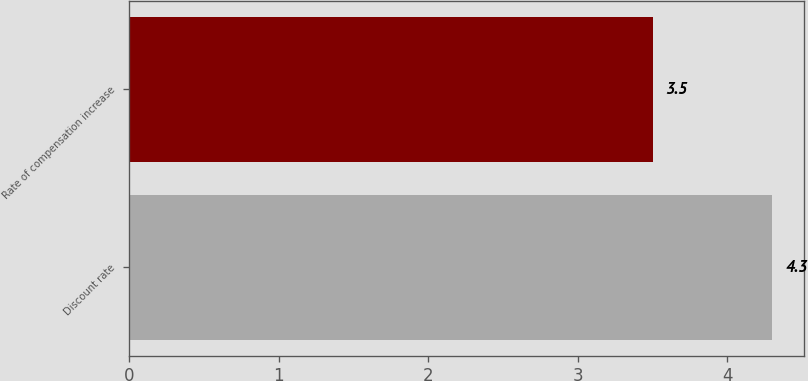Convert chart to OTSL. <chart><loc_0><loc_0><loc_500><loc_500><bar_chart><fcel>Discount rate<fcel>Rate of compensation increase<nl><fcel>4.3<fcel>3.5<nl></chart> 